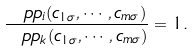<formula> <loc_0><loc_0><loc_500><loc_500>\frac { \ p p _ { i } ( c _ { 1 \sigma } , \cdots , c _ { m \sigma } ) } { \ p p _ { k } ( c _ { 1 \sigma } , \cdots , c _ { m \sigma } ) } = 1 .</formula> 